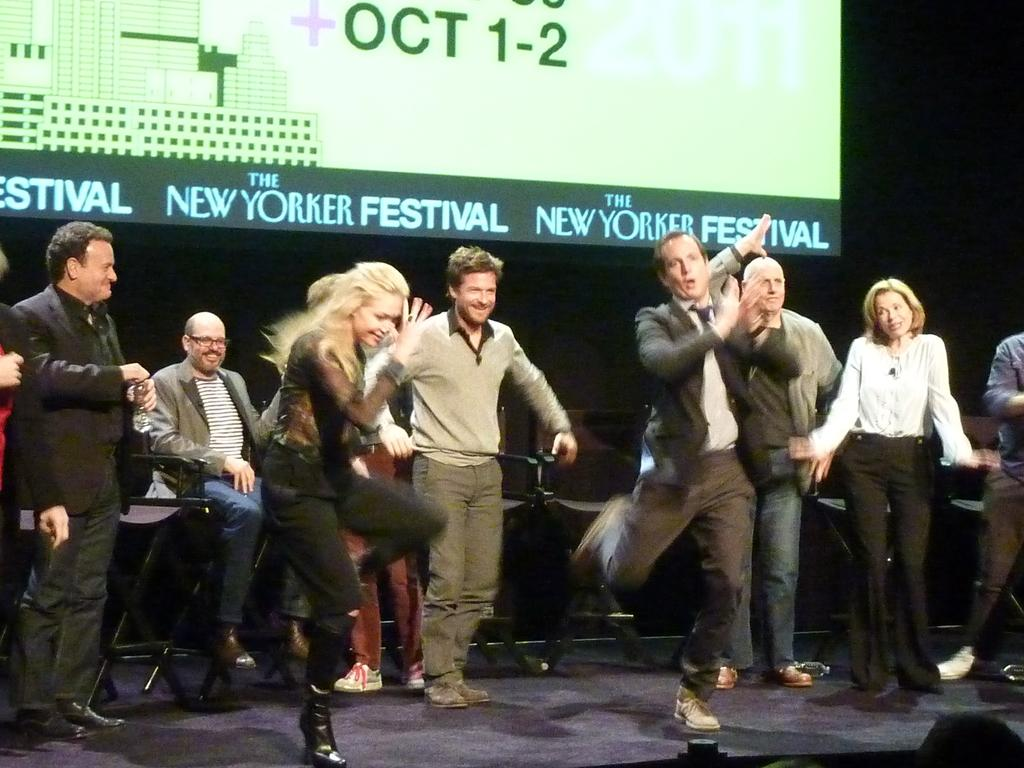What is happening in the image? There are people standing in the image. Where are the people standing? The people are standing on the floor. What is located behind the people? There are chairs behind the people. What is on the backside of the image? There is a projector screen on the backside of the image. What type of expert is depicted in the carriage scene in the image? There is no expert or carriage scene present in the image. 